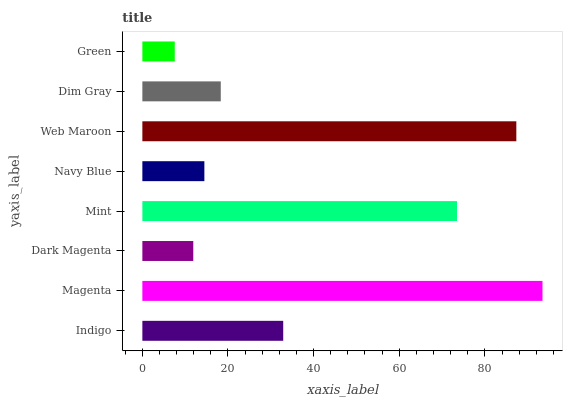Is Green the minimum?
Answer yes or no. Yes. Is Magenta the maximum?
Answer yes or no. Yes. Is Dark Magenta the minimum?
Answer yes or no. No. Is Dark Magenta the maximum?
Answer yes or no. No. Is Magenta greater than Dark Magenta?
Answer yes or no. Yes. Is Dark Magenta less than Magenta?
Answer yes or no. Yes. Is Dark Magenta greater than Magenta?
Answer yes or no. No. Is Magenta less than Dark Magenta?
Answer yes or no. No. Is Indigo the high median?
Answer yes or no. Yes. Is Dim Gray the low median?
Answer yes or no. Yes. Is Dark Magenta the high median?
Answer yes or no. No. Is Mint the low median?
Answer yes or no. No. 